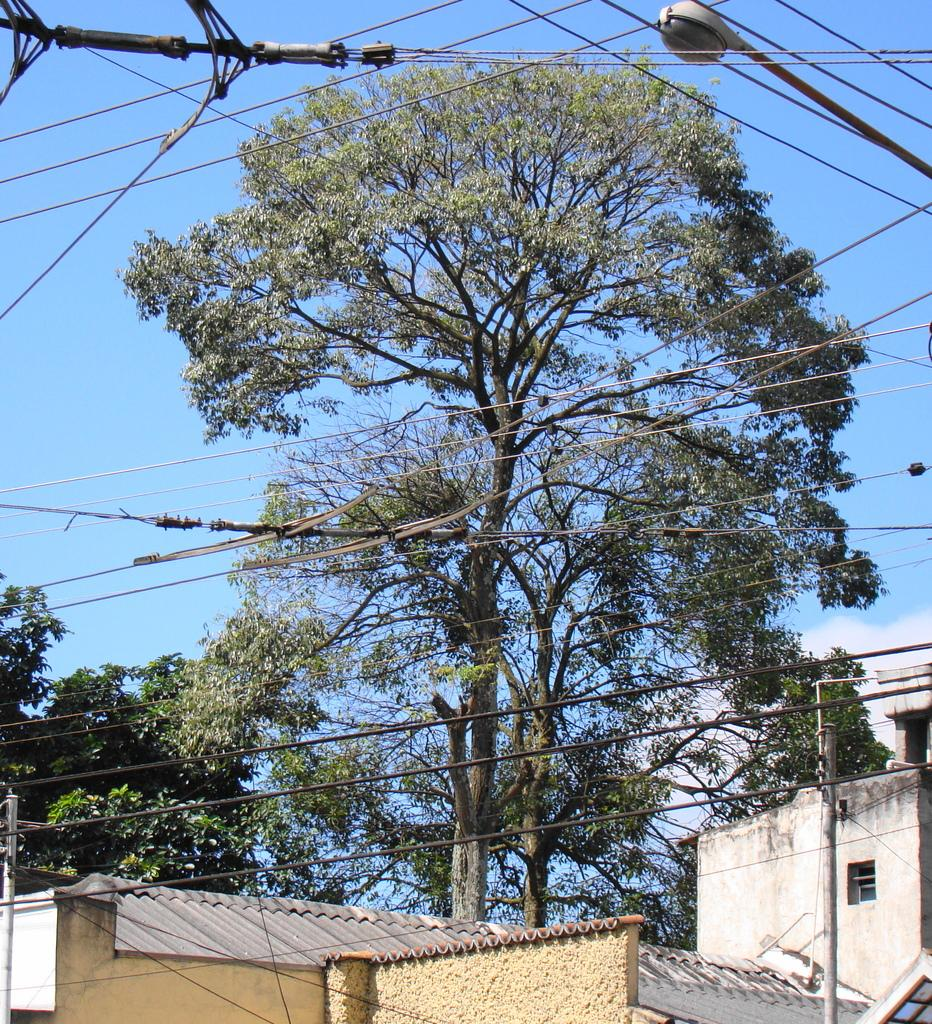What type of structures can be seen in the image? There are buildings in the image. What colors are the buildings? The buildings are in cream and gray colors. What can be seen in the background of the image? There are trees and a light pole in the background of the image. What color are the trees? The trees are green. What color is the sky in the image? The sky is blue. Can you see a robin taking a bath in the image? There is no robin or any indication of a bathing activity in the image. 